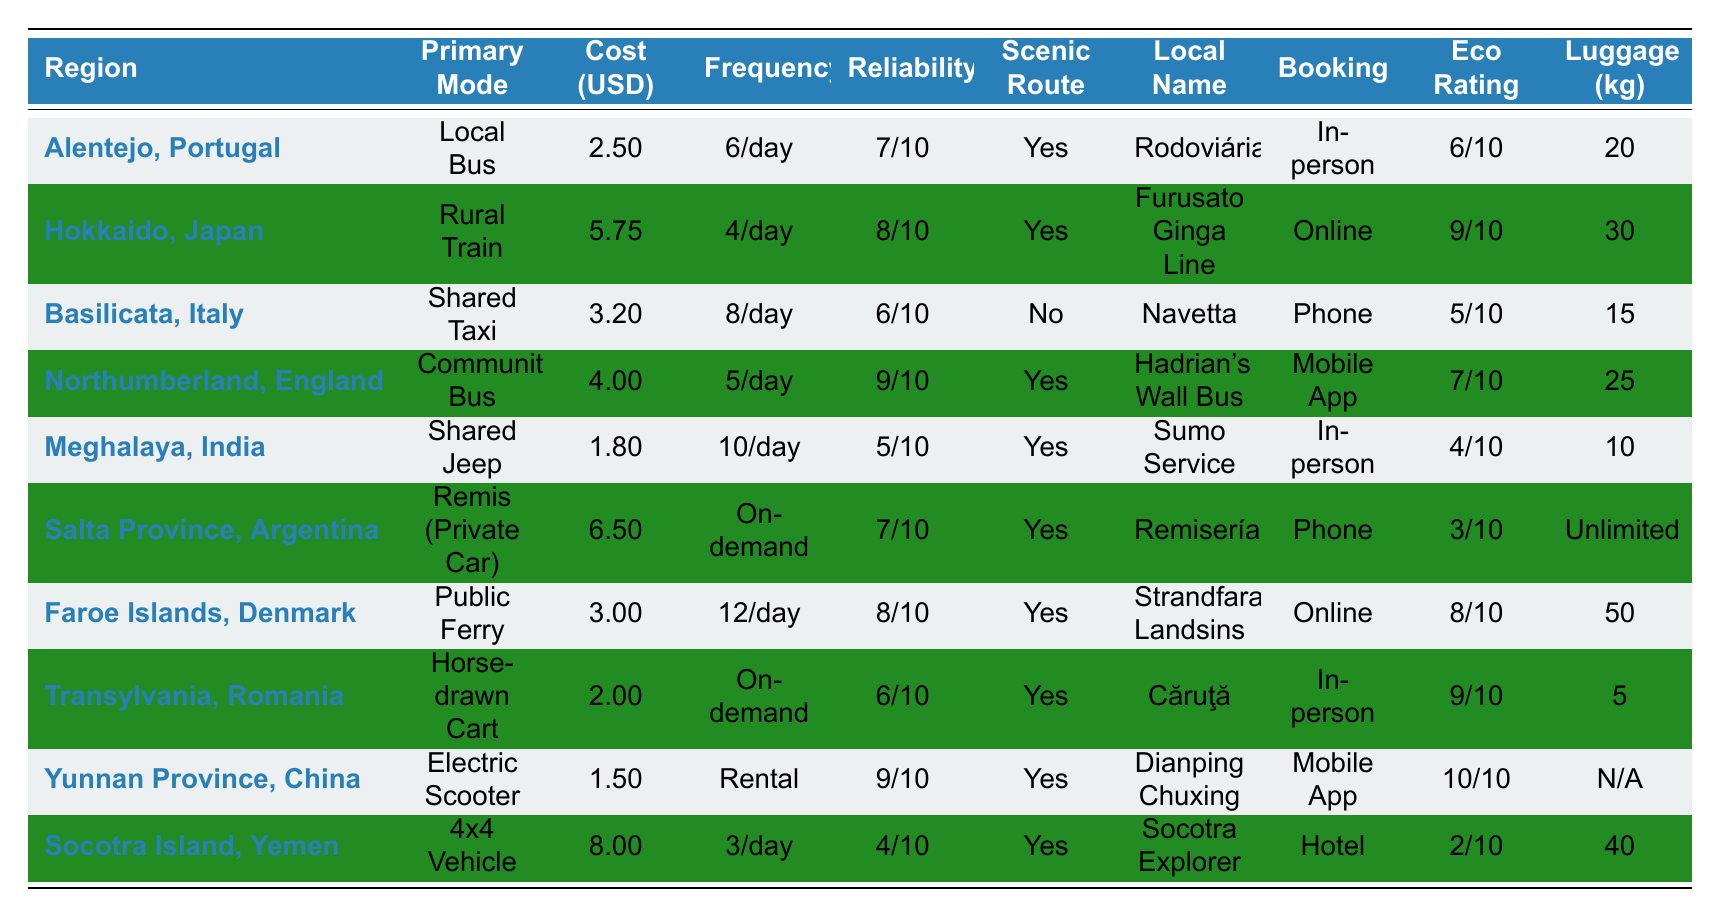What is the cost of taking a Shared Jeep in Meghalaya, India? The table indicates that the cost per trip for the Shared Jeep in Meghalaya, India, is listed as 1.80 USD.
Answer: 1.80 USD How many trips are available per day for the Public Ferry in the Faroe Islands, Denmark? The frequency for the Public Ferry is noted as 12 per day in the table.
Answer: 12 trips Which region has the highest Eco-Friendly Rating, and what is the value? By examining the Eco-Friendly Rating column, Yunnan Province, China, has the highest rating at 10.
Answer: Yunnan Province, China; 10 What is the average cost of transportation modes in the table? The total cost for all regions is (2.50 + 5.75 + 3.20 + 4.00 + 1.80 + 6.50 + 3.00 + 2.00 + 1.50 + 8.00) = 38.75, and there are 10 regions, so the average cost is 38.75 / 10 = 3.875 USD.
Answer: 3.88 USD Is there a Scenic Route available for the Horse-drawn Cart in Transylvania, Romania? The table indicates that for Transylvania, Romania, there is a Scenic Route available, marked as Yes.
Answer: Yes Which transportation mode has the lowest Reliability Score, and what is that score? Looking at the Reliability Score column, the 4x4 Vehicle in Socotra Island, Yemen has the lowest score of 4.
Answer: 4; 4x4 Vehicle How does the cost of the Remis (Private Car) compare to the cost of the Local Bus in Alentejo, Portugal? The cost for the Remis (Private Car) in Salta Province is 6.50 USD and for the Local Bus in Alentejo is 2.50 USD. The difference is 6.50 - 2.50 = 4.00 USD, indicating that the Remis is more expensive.
Answer: 4.00 USD more Are all transportation modes in the table capable of handling at least 15 kg of luggage? Evaluating the Luggage Allowance column, the Shared Jeep in Meghalaya allows only 10 kg, so not all modes can handle at least 15 kg.
Answer: No Which region offers the most frequent transportation mode and what is the frequency? By comparing the Frequency per Day column, the Public Ferry in the Faroe Islands has the most with 12 trips per day.
Answer: Faroe Islands; 12 trips How many regions provide on-demand transportation? In the Frequency per Day column, both Salta Province with Remis and Transylvania with Horse-drawn Cart are listed as On-demand, making it two regions.
Answer: 2 regions 